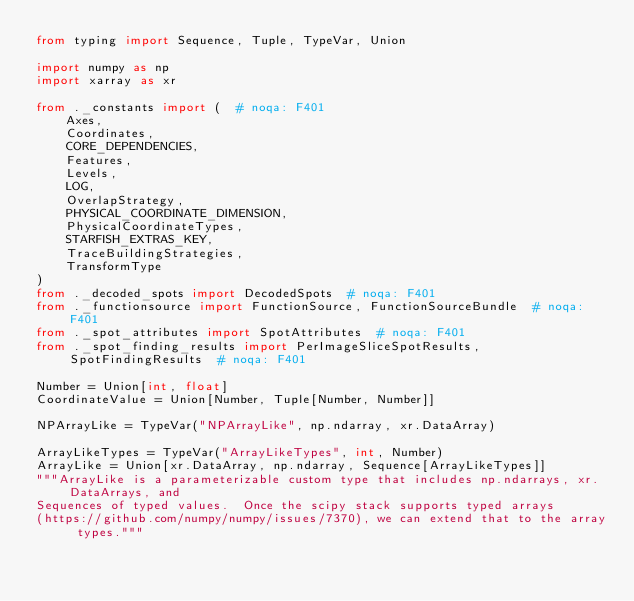<code> <loc_0><loc_0><loc_500><loc_500><_Python_>from typing import Sequence, Tuple, TypeVar, Union

import numpy as np
import xarray as xr

from ._constants import (  # noqa: F401
    Axes,
    Coordinates,
    CORE_DEPENDENCIES,
    Features,
    Levels,
    LOG,
    OverlapStrategy,
    PHYSICAL_COORDINATE_DIMENSION,
    PhysicalCoordinateTypes,
    STARFISH_EXTRAS_KEY,
    TraceBuildingStrategies,
    TransformType
)
from ._decoded_spots import DecodedSpots  # noqa: F401
from ._functionsource import FunctionSource, FunctionSourceBundle  # noqa: F401
from ._spot_attributes import SpotAttributes  # noqa: F401
from ._spot_finding_results import PerImageSliceSpotResults, SpotFindingResults  # noqa: F401

Number = Union[int, float]
CoordinateValue = Union[Number, Tuple[Number, Number]]

NPArrayLike = TypeVar("NPArrayLike", np.ndarray, xr.DataArray)

ArrayLikeTypes = TypeVar("ArrayLikeTypes", int, Number)
ArrayLike = Union[xr.DataArray, np.ndarray, Sequence[ArrayLikeTypes]]
"""ArrayLike is a parameterizable custom type that includes np.ndarrays, xr.DataArrays, and
Sequences of typed values.  Once the scipy stack supports typed arrays
(https://github.com/numpy/numpy/issues/7370), we can extend that to the array types."""
</code> 